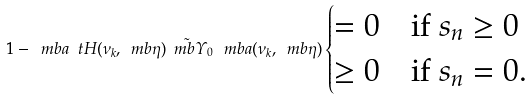<formula> <loc_0><loc_0><loc_500><loc_500>1 - \ m b { a } ^ { \ } t H ( \nu _ { k } , \ m b { \eta } ) \tilde { \ m b { \varUpsilon } } _ { 0 } \, \ m b { a } ( \nu _ { k } , \ m b { \eta } ) \begin{cases} = 0 \quad \text {if } s _ { n } \geq 0 \\ \geq 0 \quad \text {if } s _ { n } = 0 . \end{cases}</formula> 